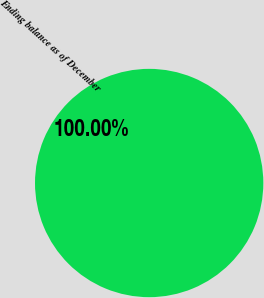Convert chart. <chart><loc_0><loc_0><loc_500><loc_500><pie_chart><fcel>Ending balance as of December<nl><fcel>100.0%<nl></chart> 